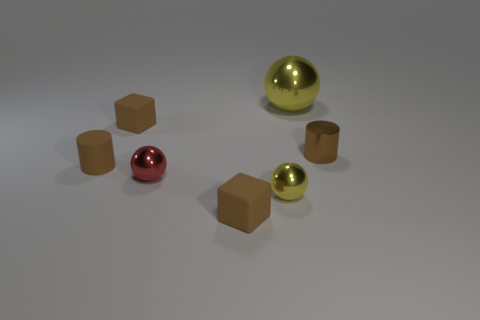Subtract all brown cylinders. How many were subtracted if there are1brown cylinders left? 1 Subtract all tiny spheres. How many spheres are left? 1 Add 2 small spheres. How many objects exist? 9 Subtract 1 cylinders. How many cylinders are left? 1 Subtract all yellow balls. How many balls are left? 1 Subtract 0 blue blocks. How many objects are left? 7 Subtract all cylinders. How many objects are left? 5 Subtract all gray balls. Subtract all green cubes. How many balls are left? 3 Subtract all blue balls. How many blue cylinders are left? 0 Subtract all large gray matte spheres. Subtract all red shiny balls. How many objects are left? 6 